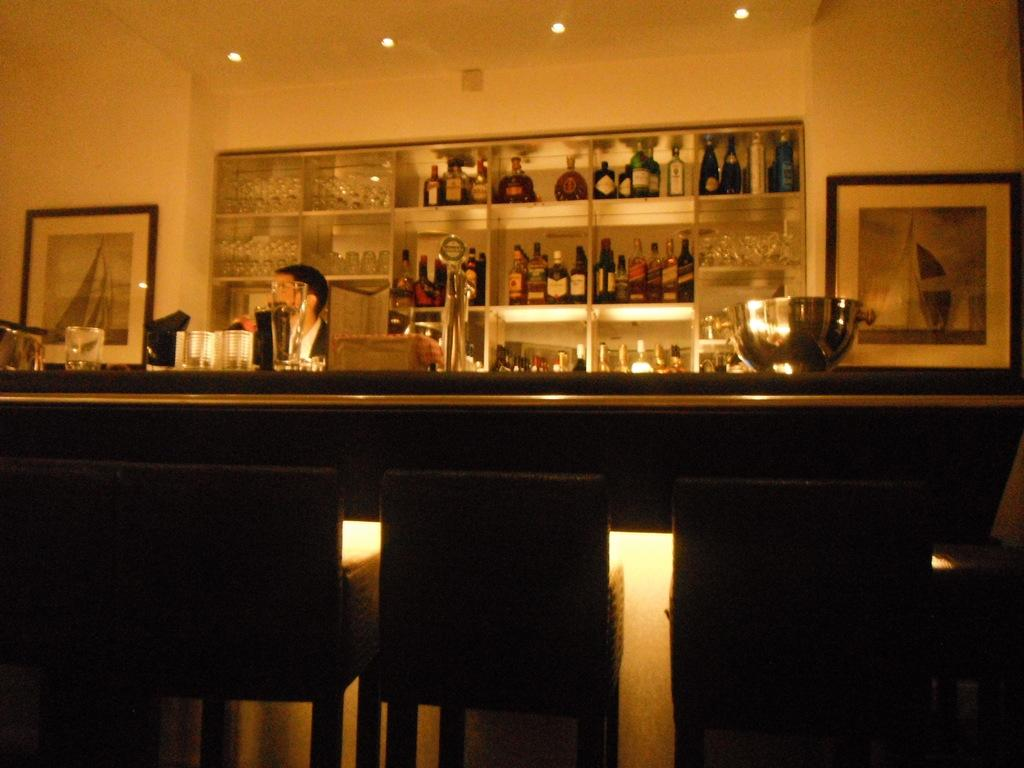What is the main feature in the center of the image? There is a bar counter in the center of the image. Who is present behind the bar counter? There is a bartender in the image. What can be seen on the shelves in the background of the image? There are wine bottles in the shelf in the background of the image. Can you see any ducks swimming in the glasses on the bar counter? There are no ducks or swimming activity present in the image; it features a bar counter with a bartender and wine bottles on the shelves. 